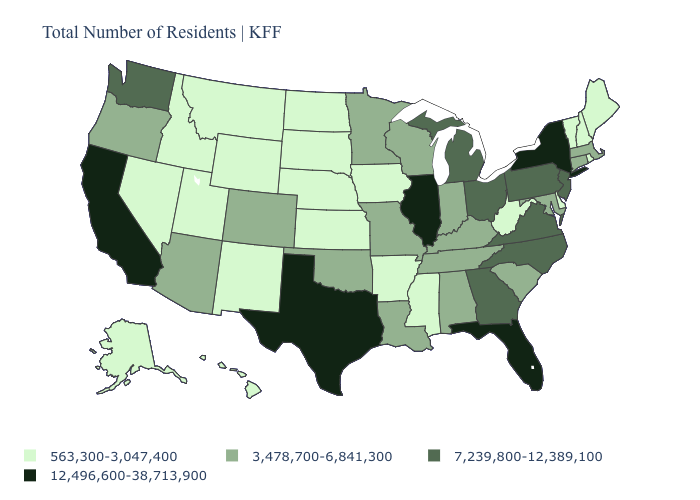What is the value of Minnesota?
Answer briefly. 3,478,700-6,841,300. Does the map have missing data?
Quick response, please. No. Name the states that have a value in the range 7,239,800-12,389,100?
Give a very brief answer. Georgia, Michigan, New Jersey, North Carolina, Ohio, Pennsylvania, Virginia, Washington. What is the value of Rhode Island?
Keep it brief. 563,300-3,047,400. What is the value of Maryland?
Concise answer only. 3,478,700-6,841,300. Among the states that border Oregon , does Nevada have the highest value?
Quick response, please. No. Name the states that have a value in the range 12,496,600-38,713,900?
Write a very short answer. California, Florida, Illinois, New York, Texas. How many symbols are there in the legend?
Give a very brief answer. 4. Name the states that have a value in the range 7,239,800-12,389,100?
Keep it brief. Georgia, Michigan, New Jersey, North Carolina, Ohio, Pennsylvania, Virginia, Washington. Does Wisconsin have the same value as Kentucky?
Keep it brief. Yes. What is the value of Kentucky?
Write a very short answer. 3,478,700-6,841,300. What is the value of Iowa?
Write a very short answer. 563,300-3,047,400. What is the highest value in the USA?
Quick response, please. 12,496,600-38,713,900. 